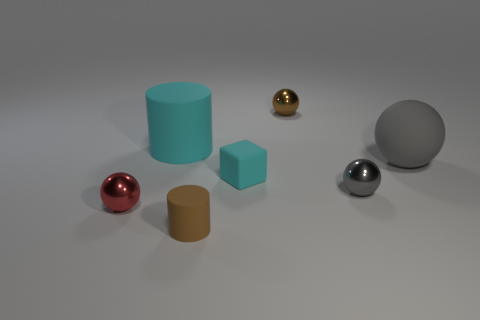The matte object that is the same shape as the tiny gray metallic object is what size?
Your answer should be very brief. Large. Are there the same number of rubber cylinders that are to the left of the cyan cylinder and gray things in front of the small red metallic ball?
Provide a short and direct response. Yes. What material is the small thing that is both to the left of the cyan matte cube and behind the small rubber cylinder?
Ensure brevity in your answer.  Metal. Do the cyan rubber cylinder and the rubber thing that is on the right side of the small brown shiny sphere have the same size?
Offer a very short reply. Yes. Is the number of red metallic balls to the left of the tiny cylinder greater than the number of tiny blue blocks?
Provide a short and direct response. Yes. What is the color of the tiny shiny thing that is on the left side of the shiny ball behind the big cyan matte thing behind the tiny gray metal sphere?
Keep it short and to the point. Red. Is the tiny gray object made of the same material as the tiny cyan thing?
Provide a short and direct response. No. Is there a cyan rubber block of the same size as the brown cylinder?
Keep it short and to the point. Yes. There is a cube that is the same size as the gray metal object; what is its material?
Your answer should be compact. Rubber. Are there any tiny red things that have the same shape as the brown metallic object?
Offer a very short reply. Yes. 